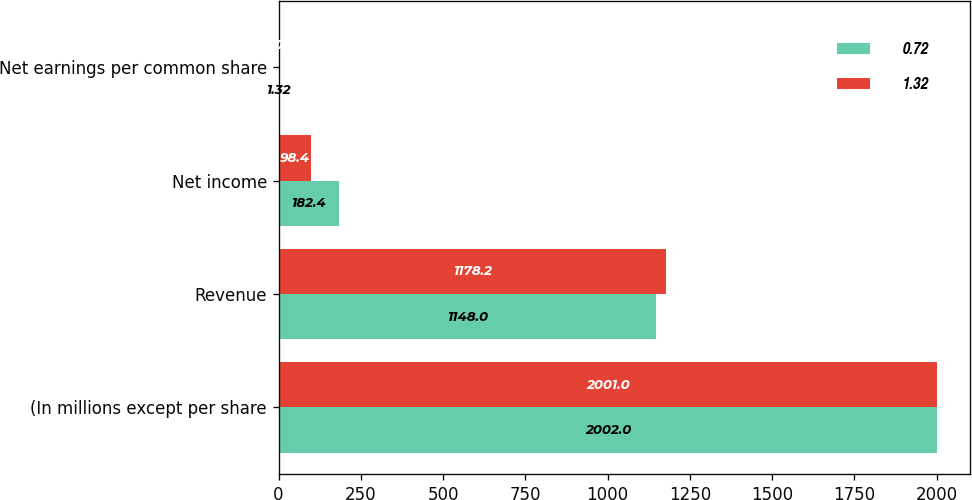Convert chart. <chart><loc_0><loc_0><loc_500><loc_500><stacked_bar_chart><ecel><fcel>(In millions except per share<fcel>Revenue<fcel>Net income<fcel>Net earnings per common share<nl><fcel>0.72<fcel>2002<fcel>1148<fcel>182.4<fcel>1.32<nl><fcel>1.32<fcel>2001<fcel>1178.2<fcel>98.4<fcel>0.72<nl></chart> 